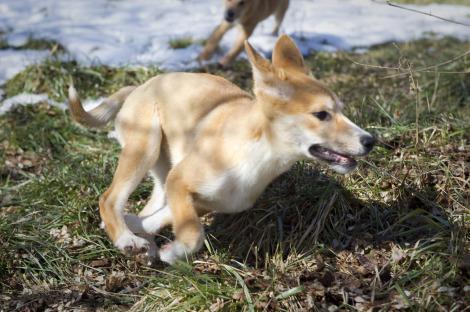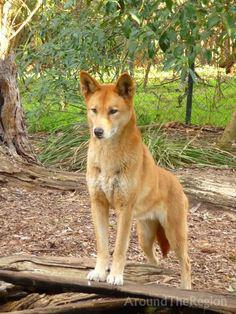The first image is the image on the left, the second image is the image on the right. Given the left and right images, does the statement "Each picture has 1 dog" hold true? Answer yes or no. Yes. 